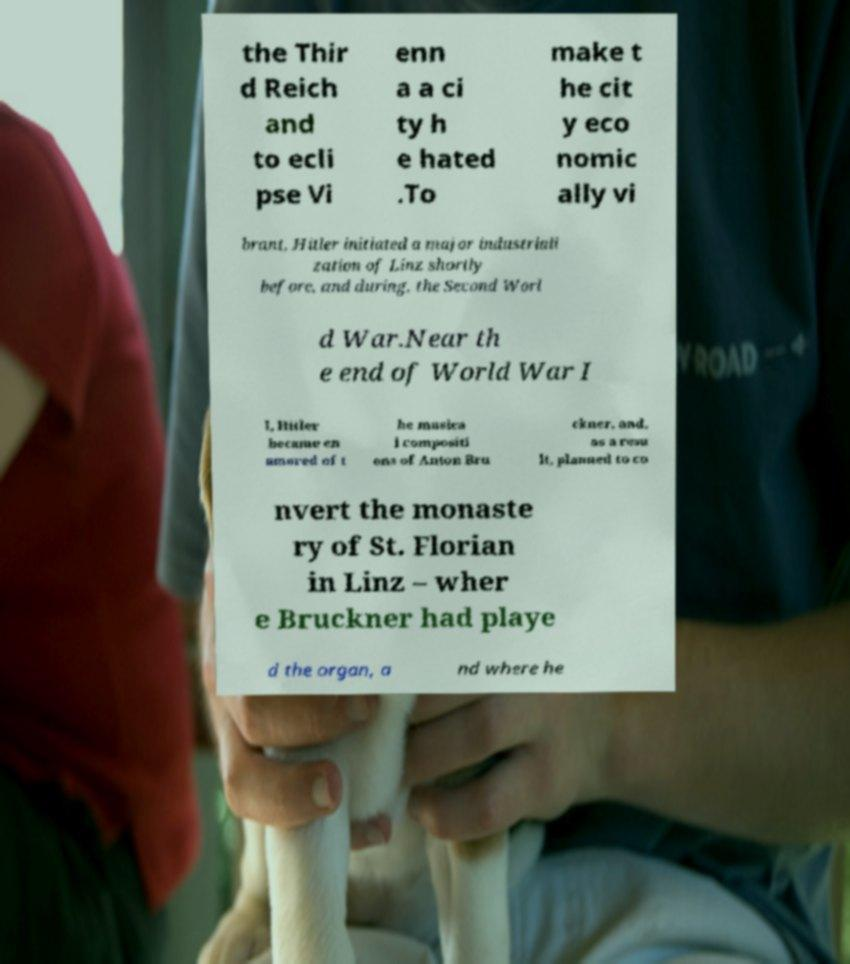Could you assist in decoding the text presented in this image and type it out clearly? the Thir d Reich and to ecli pse Vi enn a a ci ty h e hated .To make t he cit y eco nomic ally vi brant, Hitler initiated a major industriali zation of Linz shortly before, and during, the Second Worl d War.Near th e end of World War I I, Hitler became en amored of t he musica l compositi ons of Anton Bru ckner, and, as a resu lt, planned to co nvert the monaste ry of St. Florian in Linz – wher e Bruckner had playe d the organ, a nd where he 